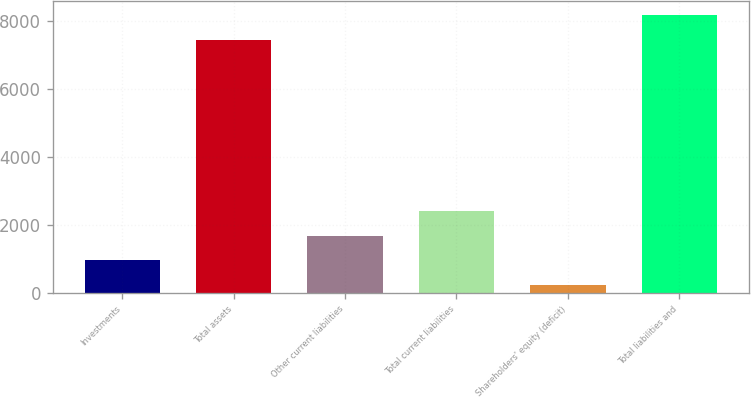<chart> <loc_0><loc_0><loc_500><loc_500><bar_chart><fcel>Investments<fcel>Total assets<fcel>Other current liabilities<fcel>Total current liabilities<fcel>Shareholders' equity (deficit)<fcel>Total liabilities and<nl><fcel>956<fcel>7445<fcel>1677<fcel>2398<fcel>235<fcel>8166<nl></chart> 